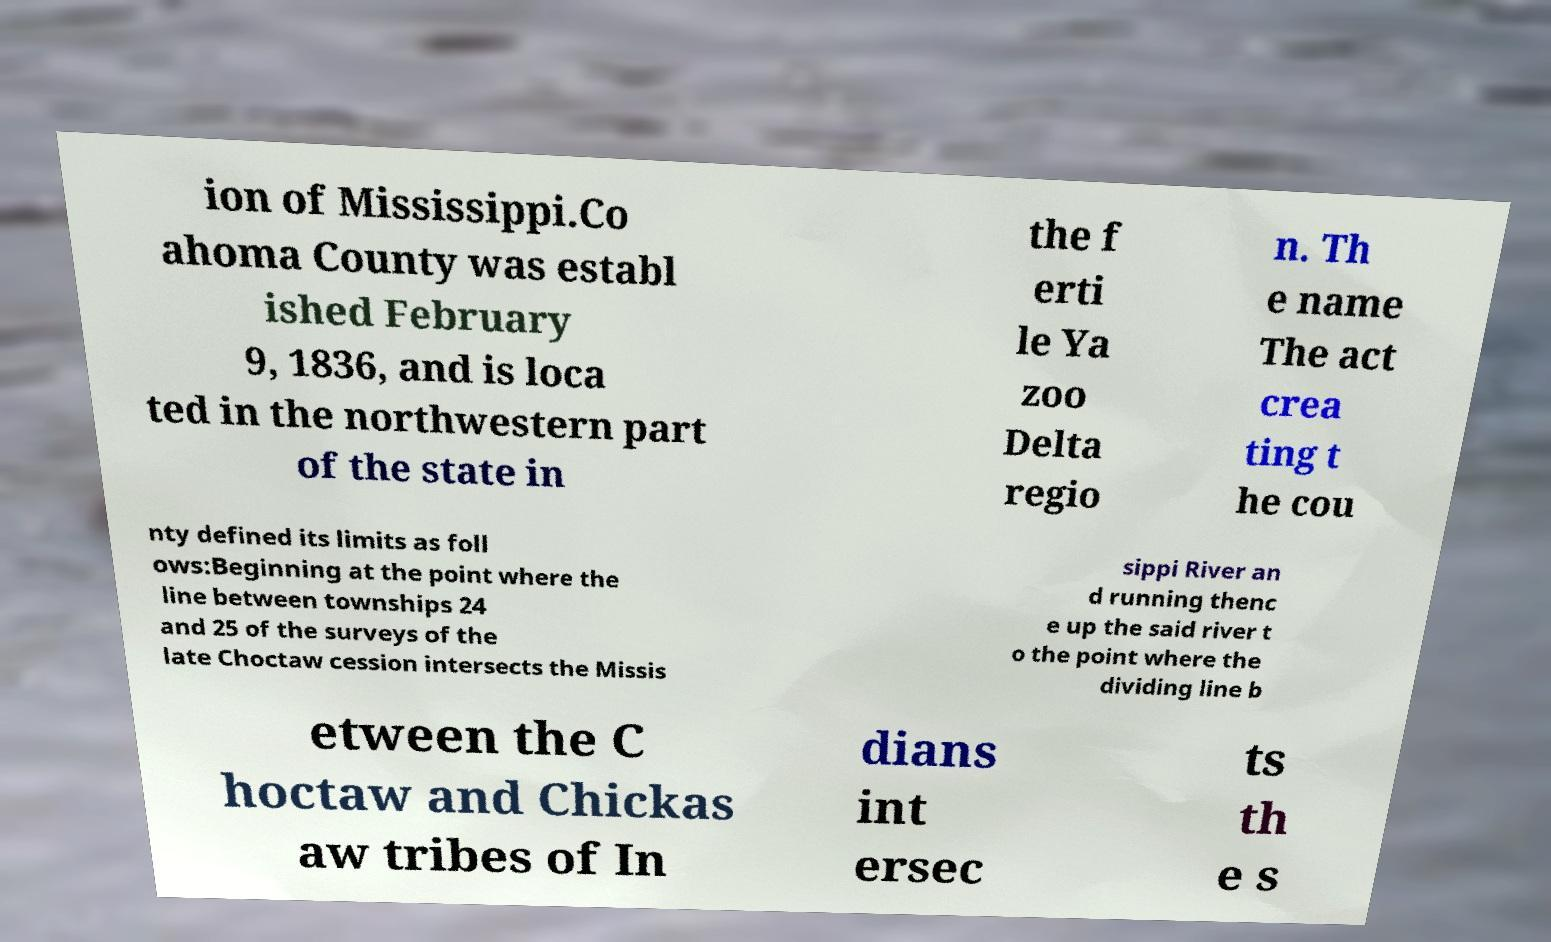I need the written content from this picture converted into text. Can you do that? ion of Mississippi.Co ahoma County was establ ished February 9, 1836, and is loca ted in the northwestern part of the state in the f erti le Ya zoo Delta regio n. Th e name The act crea ting t he cou nty defined its limits as foll ows:Beginning at the point where the line between townships 24 and 25 of the surveys of the late Choctaw cession intersects the Missis sippi River an d running thenc e up the said river t o the point where the dividing line b etween the C hoctaw and Chickas aw tribes of In dians int ersec ts th e s 